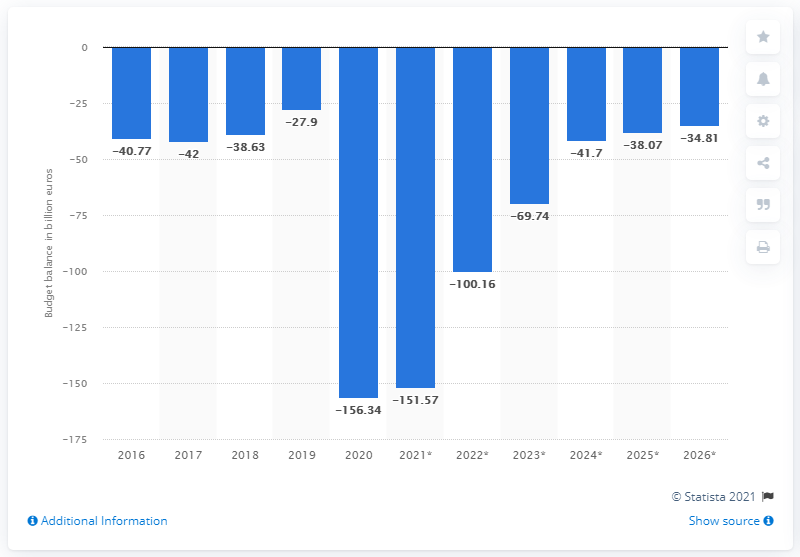Highlight a few significant elements in this photo. In what year did Italy's budget balance end? The budget balance of Italy ended in 2020. 